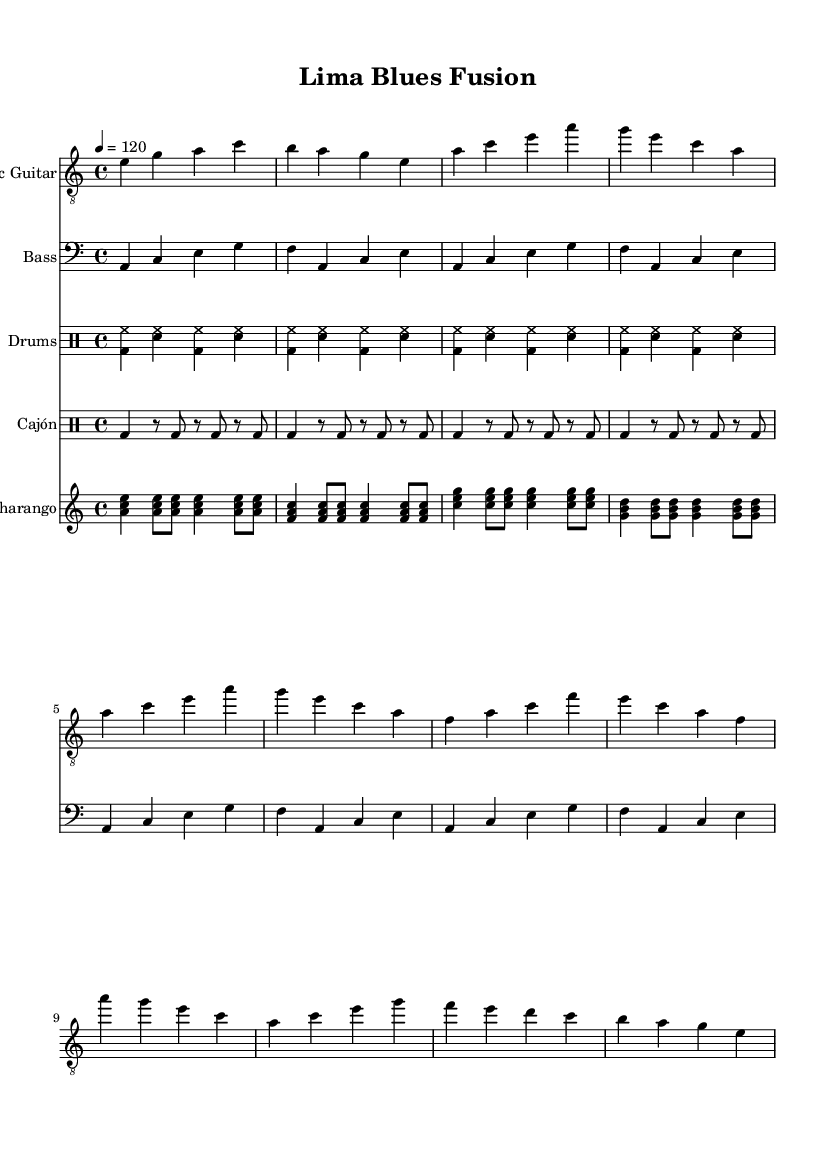What is the key signature of this music? The key signature shows two flats, indicating that the music is in the key of A minor, which is the relative minor of C major. There are no sharps and only these two flats in the signature.
Answer: A minor What is the time signature of this music? The time signature indicated at the beginning of the music is four beats per measure, denoted as 4/4. This means there are four quarter note beats in each measure.
Answer: 4/4 What tempo marking is given for the music? The tempo marking indicates that the piece should be played at a speed of 120 beats per minute, which is typically marked in quarter notes as '4 = 120'.
Answer: 120 How many bars are in the Intro section of the Electric Guitar part? The Intro section consists of four measures, as indicated by the sequence of notes before moving on to the Verse. Counting the measures visually confirms a total of four bars.
Answer: 4 What rhythm pattern does the Cajón part utilize? The Cajón part features an Afro-Peruvian rhythm pattern, characterized by a specific sequence of bass drum hits punctuated by rests, effectively creating a syncopated feel typical in Peruvian music.
Answer: Afro-Peruvian What is the primary instrument used for the lead melody in this sheet music? The primary instrument used for the lead melody is the Electric Guitar, which is prominently featured in the first staff and carries the main musical theme throughout the piece.
Answer: Electric Guitar How does the Charango contribute to the overall texture of the music? The Charango adds a distinct layer of harmonic richness with its strumming patterns, providing both rhythmic support and melodic embellishment that complement the Electric Guitar and percussion.
Answer: Harmonically 